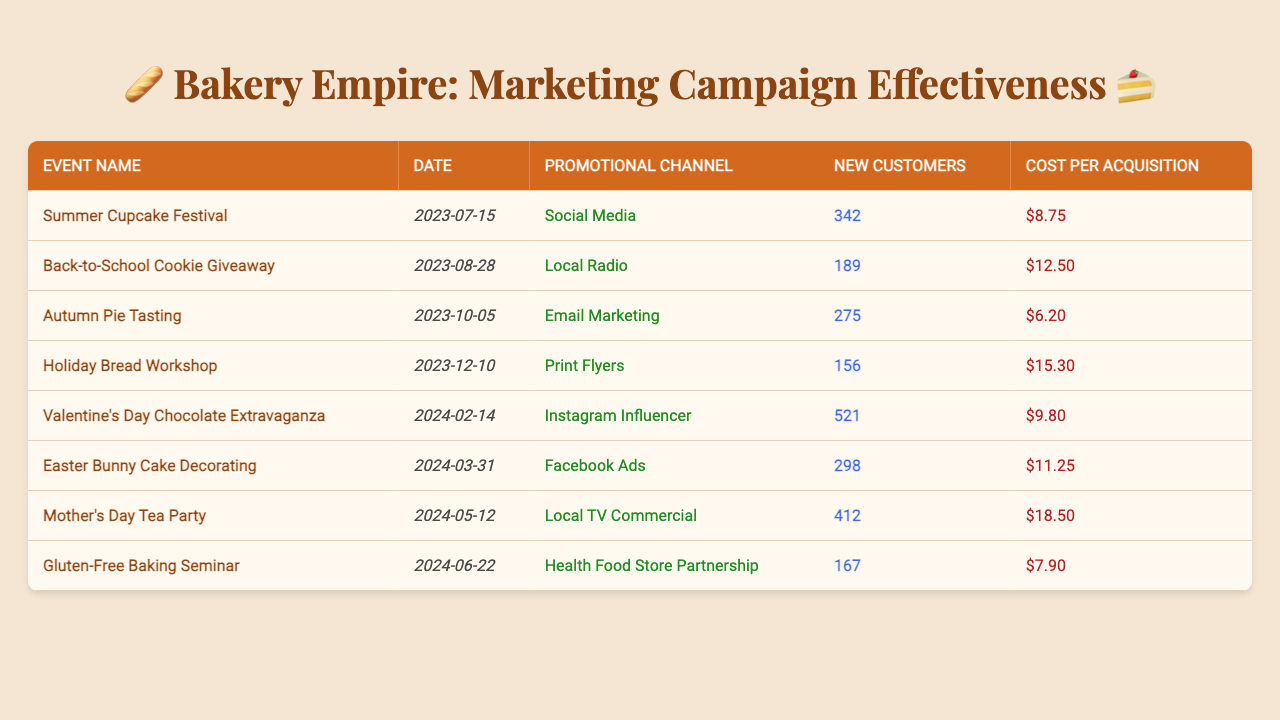What is the event that acquired the most new customers? The table shows the number of new customers acquired for each marketing event. By looking through the values in the "New Customers" column, the "Valentine's Day Chocolate Extravaganza" acquired the highest number of new customers at 521.
Answer: Valentine's Day Chocolate Extravaganza What was the cost per acquisition for the "Autumn Pie Tasting" event? The "Autumn Pie Tasting" event is listed in the table with its respective cost per acquisition in the "Cost per Acquisition" column. The value shown is $6.20.
Answer: $6.20 How many new customers were acquired during the "Mother's Day Tea Party"? Referring to the table, the number of new customers acquired during the "Mother's Day Tea Party" is found in the "New Customers" column, which shows 412 new customers.
Answer: 412 What is the total number of new customers acquired across all events? To find the total, sum the "New Customers" column: 342 + 189 + 275 + 156 + 521 + 298 + 412 + 167 = 1960. Thus, the total number of new customers acquired is 1960.
Answer: 1960 Which promotional channel had the highest cost per acquisition? By examining the "Cost per Acquisition" values for each promotional channel, the highest value is found with the "Mother's Day Tea Party" at $18.50.
Answer: Local TV Commercial Is the cost per acquisition for the "Holiday Bread Workshop" higher or lower than the average cost per acquisition across all events? First, calculate the average cost per acquisition by summing all costs: (8.75 + 12.50 + 6.20 + 15.30 + 9.80 + 11.25 + 18.50 + 7.90) / 8 = $11.22. The "Holiday Bread Workshop" cost $15.30, which is higher than the average cost.
Answer: Higher Which event had the lowest number of new customers and what was the promotional channel used? The event with the lowest number of new customers is the "Holiday Bread Workshop" with 156 new customers, and it utilized the "Print Flyers" promotional channel.
Answer: Holiday Bread Workshop, Print Flyers How much did the bakery spend per new customer at the "Easter Bunny Cake Decorating" event? The cost per acquisition for this event is listed as $11.25 in the table. This is the amount spent per new customer for this event.
Answer: $11.25 What is the average number of new customers acquired across all events? To find the average, sum the new customers and divide by the number of events: (342 + 189 + 275 + 156 + 521 + 298 + 412 + 167) / 8 = 245.
Answer: 245 Which event had the most cost-effective customer acquisition based on its cost per acquisition? The event with the lowest cost per acquisition is the "Autumn Pie Tasting" at $6.20 per new customer, making it the most cost-effective in the table.
Answer: Autumn Pie Tasting 